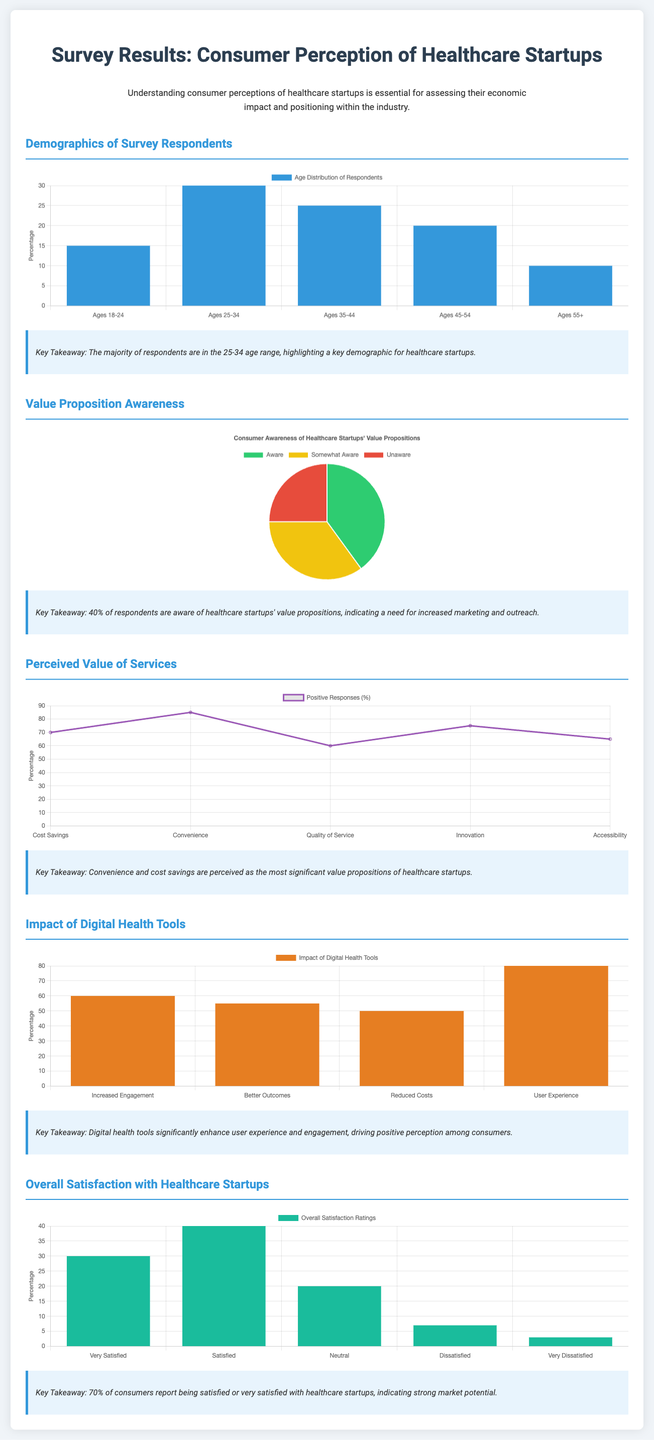What is the age demographic with the highest representation? The demographics chart shows the age distribution, where the highest percentage is in the 25-34 age range, at 30%.
Answer: 25-34 What percentage of respondents are aware of healthcare startups' value propositions? The awareness chart displays that 40% of respondents are aware of these value propositions.
Answer: 40% What is considered the most significant perceived value proposition of healthcare startups? The value chart indicates that convenience is perceived as the most significant value proposition.
Answer: Convenience What is the impact percentage of digital health tools on user experience? The impact chart highlights that user experience is impacted positively by 80%.
Answer: 80% What percentage of consumers report being either satisfied or very satisfied with healthcare startups? The satisfaction chart shows that 70% of consumers report being satisfied or very satisfied.
Answer: 70% Which age group represents the lowest percentage in the demographics? The demographics chart indicates that the ages 55+ group has the lowest representation at 10%.
Answer: 55+ How many response categories are there for overall satisfaction ratings? The satisfaction chart outlines five response categories for overall satisfaction ratings.
Answer: Five Which digital health tool impact received the highest rating? The impact chart reveals that increased engagement received the highest rating at 60%.
Answer: Increased Engagement What type of chart is used to display consumer awareness of healthcare startups? The awareness chart is displayed as a pie chart.
Answer: Pie chart 